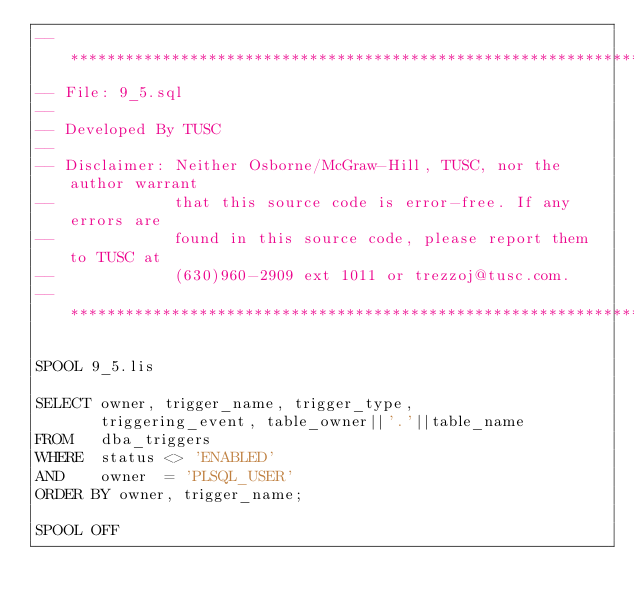<code> <loc_0><loc_0><loc_500><loc_500><_SQL_>-- ***************************************************************************
-- File: 9_5.sql
--
-- Developed By TUSC
--
-- Disclaimer: Neither Osborne/McGraw-Hill, TUSC, nor the author warrant
--             that this source code is error-free. If any errors are
--             found in this source code, please report them to TUSC at
--             (630)960-2909 ext 1011 or trezzoj@tusc.com.
-- ***************************************************************************

SPOOL 9_5.lis

SELECT owner, trigger_name, trigger_type,
       triggering_event, table_owner||'.'||table_name
FROM   dba_triggers
WHERE  status <> 'ENABLED'
AND    owner  = 'PLSQL_USER'
ORDER BY owner, trigger_name;

SPOOL OFF
</code> 